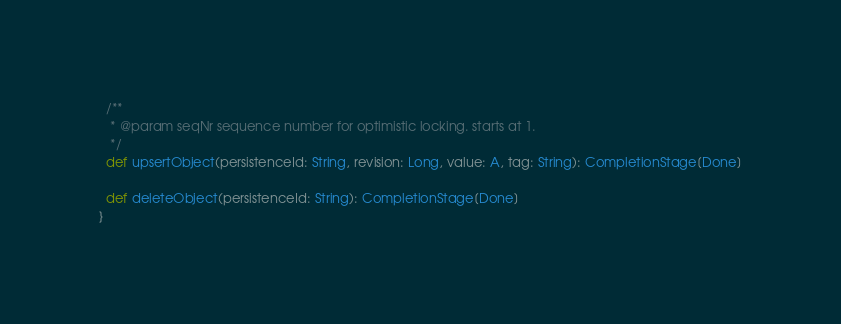<code> <loc_0><loc_0><loc_500><loc_500><_Scala_>  /**
   * @param seqNr sequence number for optimistic locking. starts at 1.
   */
  def upsertObject(persistenceId: String, revision: Long, value: A, tag: String): CompletionStage[Done]

  def deleteObject(persistenceId: String): CompletionStage[Done]
}
</code> 